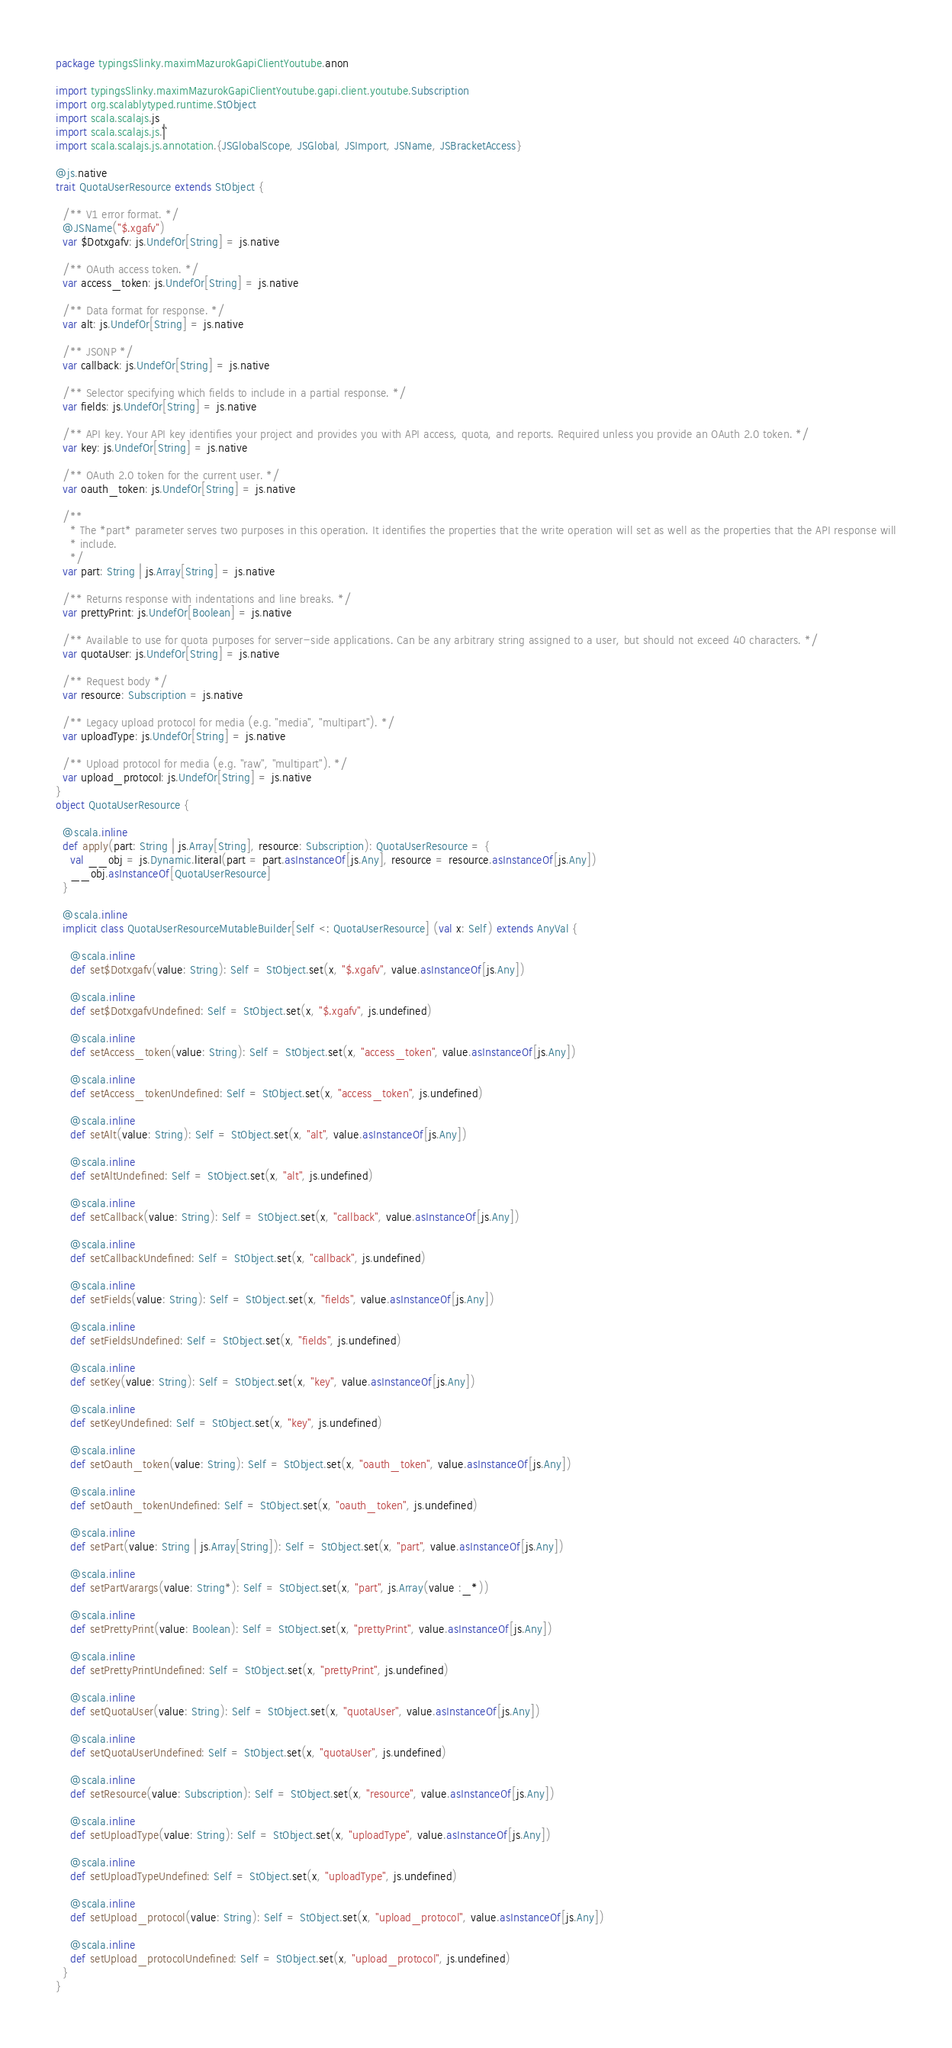Convert code to text. <code><loc_0><loc_0><loc_500><loc_500><_Scala_>package typingsSlinky.maximMazurokGapiClientYoutube.anon

import typingsSlinky.maximMazurokGapiClientYoutube.gapi.client.youtube.Subscription
import org.scalablytyped.runtime.StObject
import scala.scalajs.js
import scala.scalajs.js.`|`
import scala.scalajs.js.annotation.{JSGlobalScope, JSGlobal, JSImport, JSName, JSBracketAccess}

@js.native
trait QuotaUserResource extends StObject {
  
  /** V1 error format. */
  @JSName("$.xgafv")
  var $Dotxgafv: js.UndefOr[String] = js.native
  
  /** OAuth access token. */
  var access_token: js.UndefOr[String] = js.native
  
  /** Data format for response. */
  var alt: js.UndefOr[String] = js.native
  
  /** JSONP */
  var callback: js.UndefOr[String] = js.native
  
  /** Selector specifying which fields to include in a partial response. */
  var fields: js.UndefOr[String] = js.native
  
  /** API key. Your API key identifies your project and provides you with API access, quota, and reports. Required unless you provide an OAuth 2.0 token. */
  var key: js.UndefOr[String] = js.native
  
  /** OAuth 2.0 token for the current user. */
  var oauth_token: js.UndefOr[String] = js.native
  
  /**
    * The *part* parameter serves two purposes in this operation. It identifies the properties that the write operation will set as well as the properties that the API response will
    * include.
    */
  var part: String | js.Array[String] = js.native
  
  /** Returns response with indentations and line breaks. */
  var prettyPrint: js.UndefOr[Boolean] = js.native
  
  /** Available to use for quota purposes for server-side applications. Can be any arbitrary string assigned to a user, but should not exceed 40 characters. */
  var quotaUser: js.UndefOr[String] = js.native
  
  /** Request body */
  var resource: Subscription = js.native
  
  /** Legacy upload protocol for media (e.g. "media", "multipart"). */
  var uploadType: js.UndefOr[String] = js.native
  
  /** Upload protocol for media (e.g. "raw", "multipart"). */
  var upload_protocol: js.UndefOr[String] = js.native
}
object QuotaUserResource {
  
  @scala.inline
  def apply(part: String | js.Array[String], resource: Subscription): QuotaUserResource = {
    val __obj = js.Dynamic.literal(part = part.asInstanceOf[js.Any], resource = resource.asInstanceOf[js.Any])
    __obj.asInstanceOf[QuotaUserResource]
  }
  
  @scala.inline
  implicit class QuotaUserResourceMutableBuilder[Self <: QuotaUserResource] (val x: Self) extends AnyVal {
    
    @scala.inline
    def set$Dotxgafv(value: String): Self = StObject.set(x, "$.xgafv", value.asInstanceOf[js.Any])
    
    @scala.inline
    def set$DotxgafvUndefined: Self = StObject.set(x, "$.xgafv", js.undefined)
    
    @scala.inline
    def setAccess_token(value: String): Self = StObject.set(x, "access_token", value.asInstanceOf[js.Any])
    
    @scala.inline
    def setAccess_tokenUndefined: Self = StObject.set(x, "access_token", js.undefined)
    
    @scala.inline
    def setAlt(value: String): Self = StObject.set(x, "alt", value.asInstanceOf[js.Any])
    
    @scala.inline
    def setAltUndefined: Self = StObject.set(x, "alt", js.undefined)
    
    @scala.inline
    def setCallback(value: String): Self = StObject.set(x, "callback", value.asInstanceOf[js.Any])
    
    @scala.inline
    def setCallbackUndefined: Self = StObject.set(x, "callback", js.undefined)
    
    @scala.inline
    def setFields(value: String): Self = StObject.set(x, "fields", value.asInstanceOf[js.Any])
    
    @scala.inline
    def setFieldsUndefined: Self = StObject.set(x, "fields", js.undefined)
    
    @scala.inline
    def setKey(value: String): Self = StObject.set(x, "key", value.asInstanceOf[js.Any])
    
    @scala.inline
    def setKeyUndefined: Self = StObject.set(x, "key", js.undefined)
    
    @scala.inline
    def setOauth_token(value: String): Self = StObject.set(x, "oauth_token", value.asInstanceOf[js.Any])
    
    @scala.inline
    def setOauth_tokenUndefined: Self = StObject.set(x, "oauth_token", js.undefined)
    
    @scala.inline
    def setPart(value: String | js.Array[String]): Self = StObject.set(x, "part", value.asInstanceOf[js.Any])
    
    @scala.inline
    def setPartVarargs(value: String*): Self = StObject.set(x, "part", js.Array(value :_*))
    
    @scala.inline
    def setPrettyPrint(value: Boolean): Self = StObject.set(x, "prettyPrint", value.asInstanceOf[js.Any])
    
    @scala.inline
    def setPrettyPrintUndefined: Self = StObject.set(x, "prettyPrint", js.undefined)
    
    @scala.inline
    def setQuotaUser(value: String): Self = StObject.set(x, "quotaUser", value.asInstanceOf[js.Any])
    
    @scala.inline
    def setQuotaUserUndefined: Self = StObject.set(x, "quotaUser", js.undefined)
    
    @scala.inline
    def setResource(value: Subscription): Self = StObject.set(x, "resource", value.asInstanceOf[js.Any])
    
    @scala.inline
    def setUploadType(value: String): Self = StObject.set(x, "uploadType", value.asInstanceOf[js.Any])
    
    @scala.inline
    def setUploadTypeUndefined: Self = StObject.set(x, "uploadType", js.undefined)
    
    @scala.inline
    def setUpload_protocol(value: String): Self = StObject.set(x, "upload_protocol", value.asInstanceOf[js.Any])
    
    @scala.inline
    def setUpload_protocolUndefined: Self = StObject.set(x, "upload_protocol", js.undefined)
  }
}
</code> 